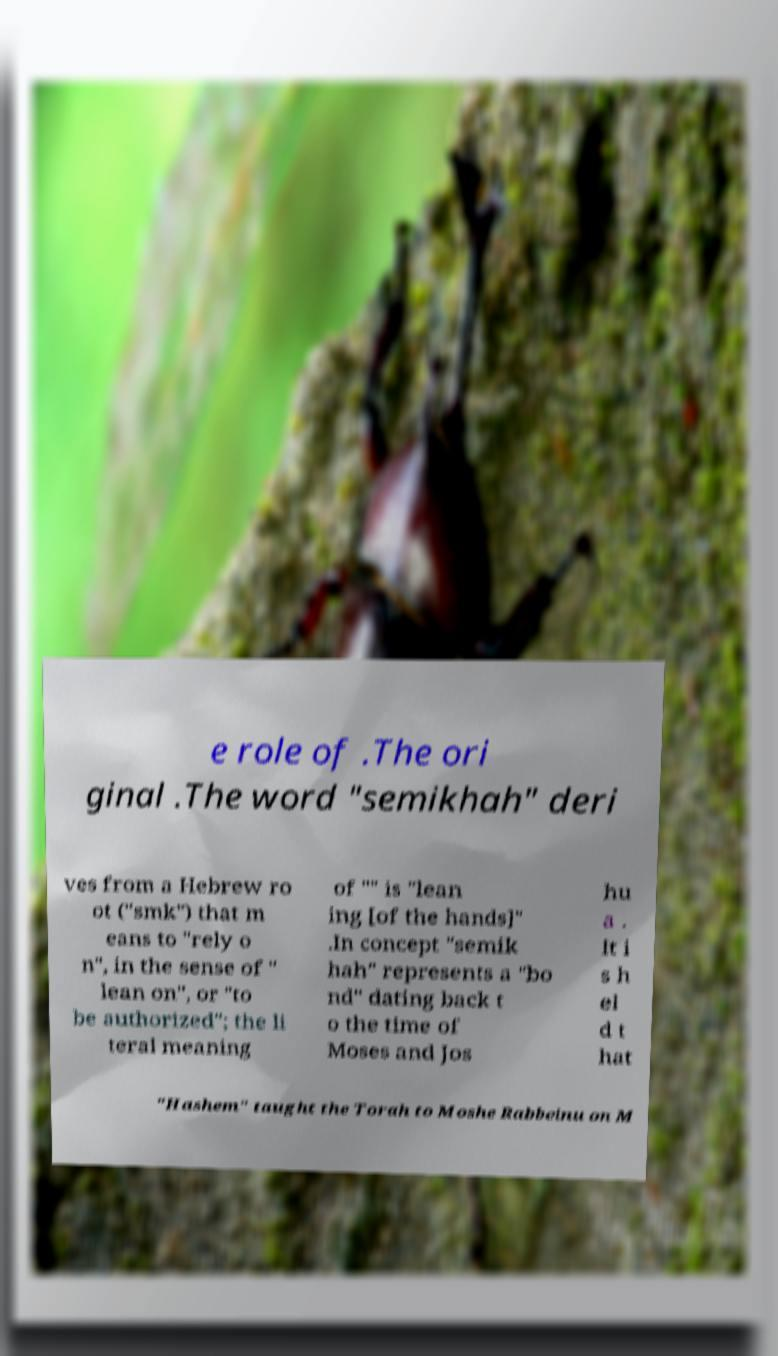Please identify and transcribe the text found in this image. e role of .The ori ginal .The word "semikhah" deri ves from a Hebrew ro ot ("smk") that m eans to "rely o n", in the sense of " lean on", or "to be authorized"; the li teral meaning of "" is "lean ing [of the hands]" .In concept "semik hah" represents a "bo nd" dating back t o the time of Moses and Jos hu a . It i s h el d t hat "Hashem" taught the Torah to Moshe Rabbeinu on M 